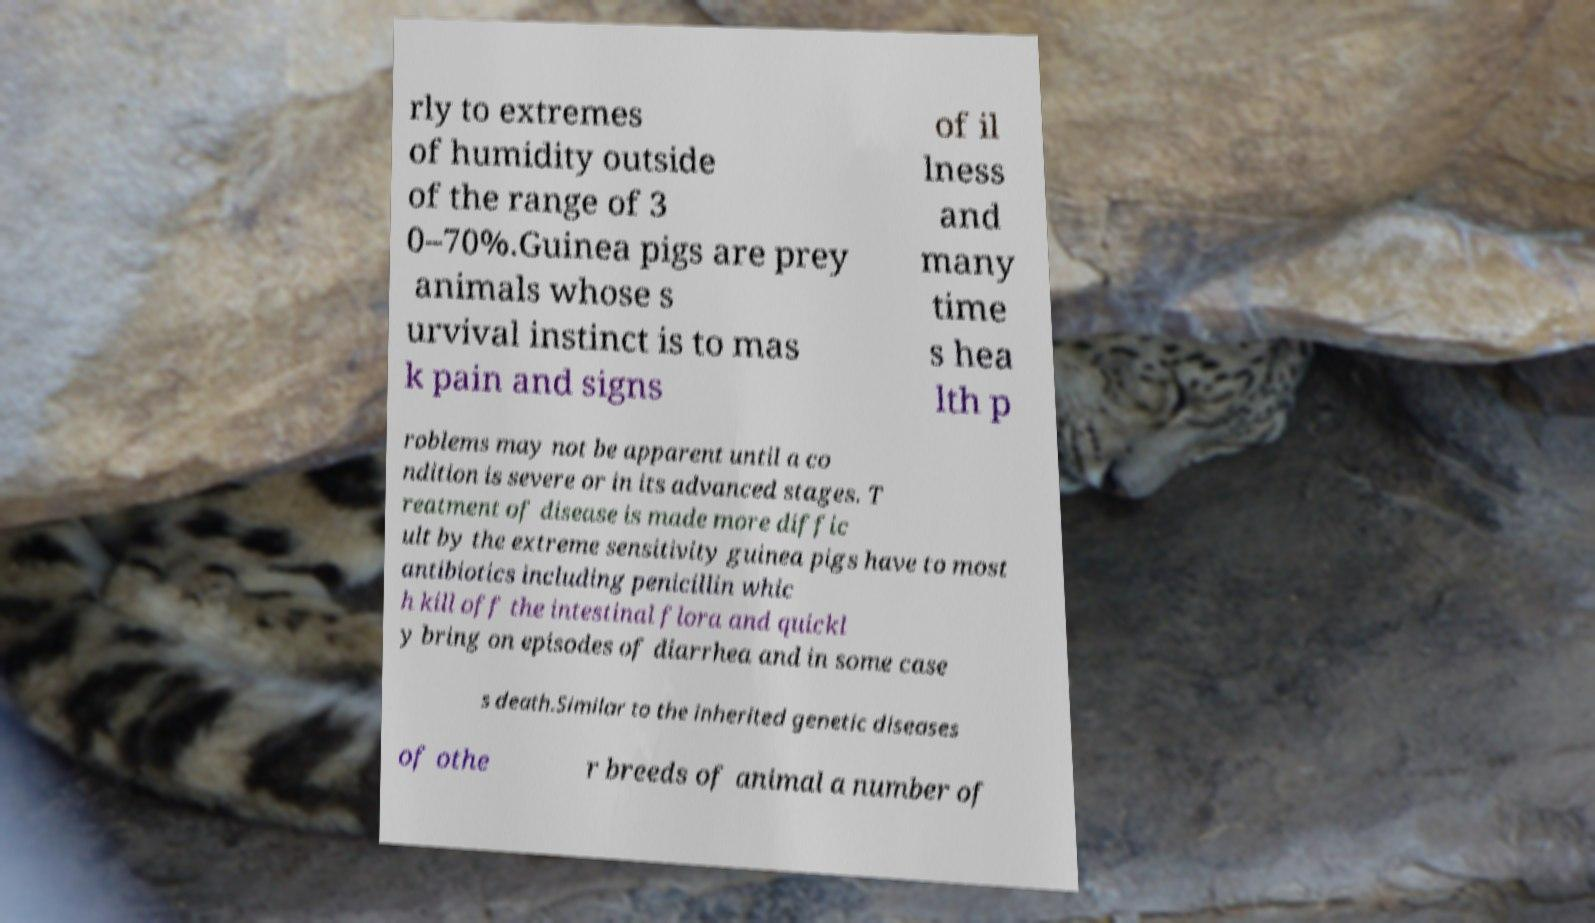Could you assist in decoding the text presented in this image and type it out clearly? rly to extremes of humidity outside of the range of 3 0–70%.Guinea pigs are prey animals whose s urvival instinct is to mas k pain and signs of il lness and many time s hea lth p roblems may not be apparent until a co ndition is severe or in its advanced stages. T reatment of disease is made more diffic ult by the extreme sensitivity guinea pigs have to most antibiotics including penicillin whic h kill off the intestinal flora and quickl y bring on episodes of diarrhea and in some case s death.Similar to the inherited genetic diseases of othe r breeds of animal a number of 